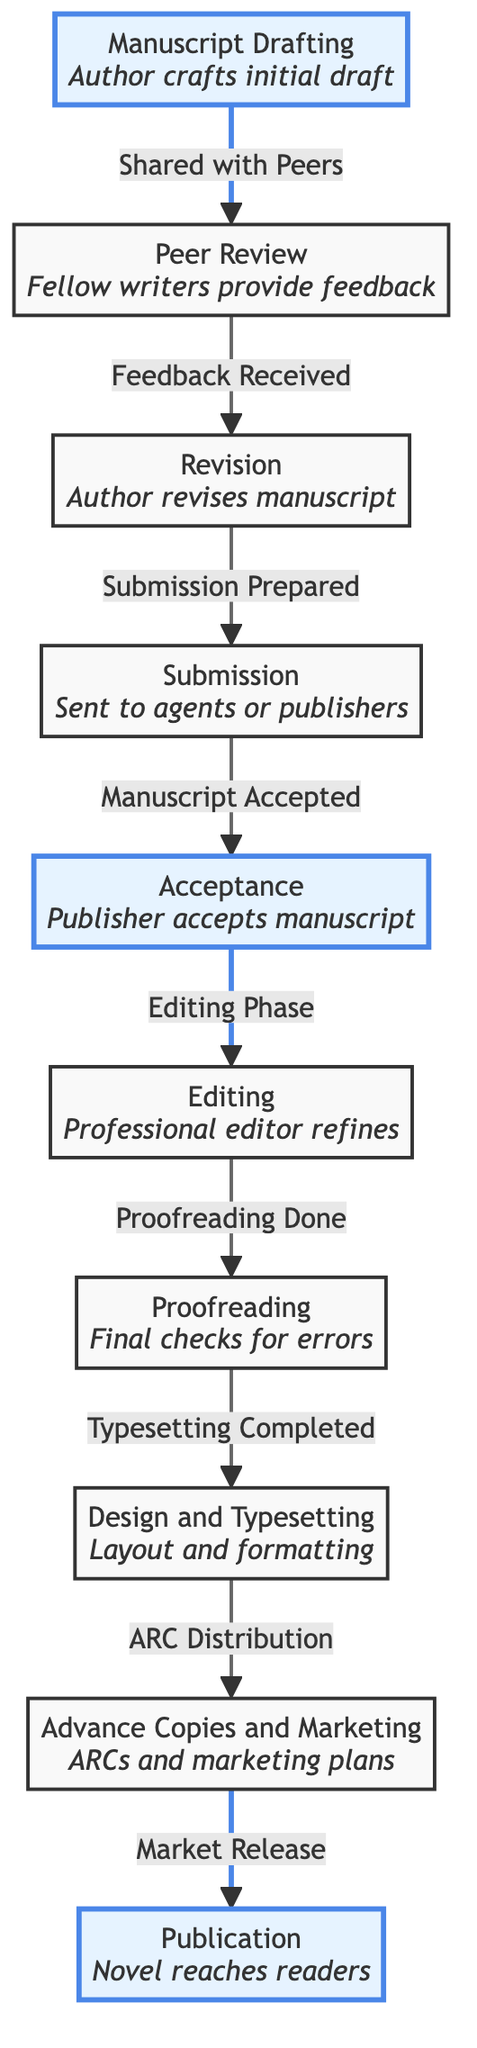What is the first stage in the evolution of a novel? The diagram indicates that the first stage in this process is "Manuscript Drafting," where the author crafts the initial draft.
Answer: Manuscript Drafting How many stages are there in total? By counting each distinct node listed in the diagram, we find that there are a total of ten stages in the evolution of a novel.
Answer: 10 What happens after the "Peer Review" stage? Following the "Peer Review" stage, the diagram shows that the next stage is the "Revision" phase, where the author revises the manuscript based on feedback.
Answer: Revision What stage involves "Advance Copies and Marketing"? The stage that encompasses "Advance Copies and Marketing" is labeled as such, which indicates this is where ARCs are created and marketing plans are established.
Answer: Advance Copies and Marketing Which stages are highlighted in the diagram? The highlighted stages in the diagram are "Manuscript Drafting," "Acceptance," and "Publication." These are emphasized with different colors to denote their significance.
Answer: Manuscript Drafting, Acceptance, Publication What marks the transition from "Submission" to "Acceptance"? The transition from "Submission" to "Acceptance" is marked by the phrase "Manuscript Accepted," indicating the publisher's approval of the submitted manuscript.
Answer: Manuscript Accepted What is the final stage of the process depicted in the diagram? The last step in the flow of the diagram is labeled "Publication," which signifies the moment when the novel reaches readers.
Answer: Publication Which stage follows "Editing"? According to the flow of the diagram, the stage that follows "Editing" is "Proofreading," which entails final checks for errors.
Answer: Proofreading What action occurs after "Proofreading Done"? The action that occurs next after "Proofreading Done" is the "Typesetting Completed," indicating the layout and formatting of the manuscript has been finalized.
Answer: Typesetting Completed 